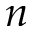<formula> <loc_0><loc_0><loc_500><loc_500>n</formula> 